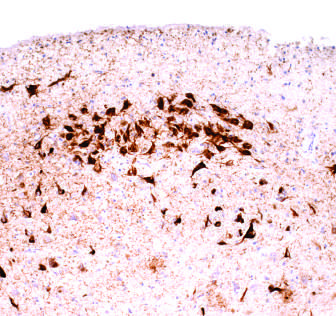re neurons containing tangles stained with an antibody specific for tau?
Answer the question using a single word or phrase. Yes 